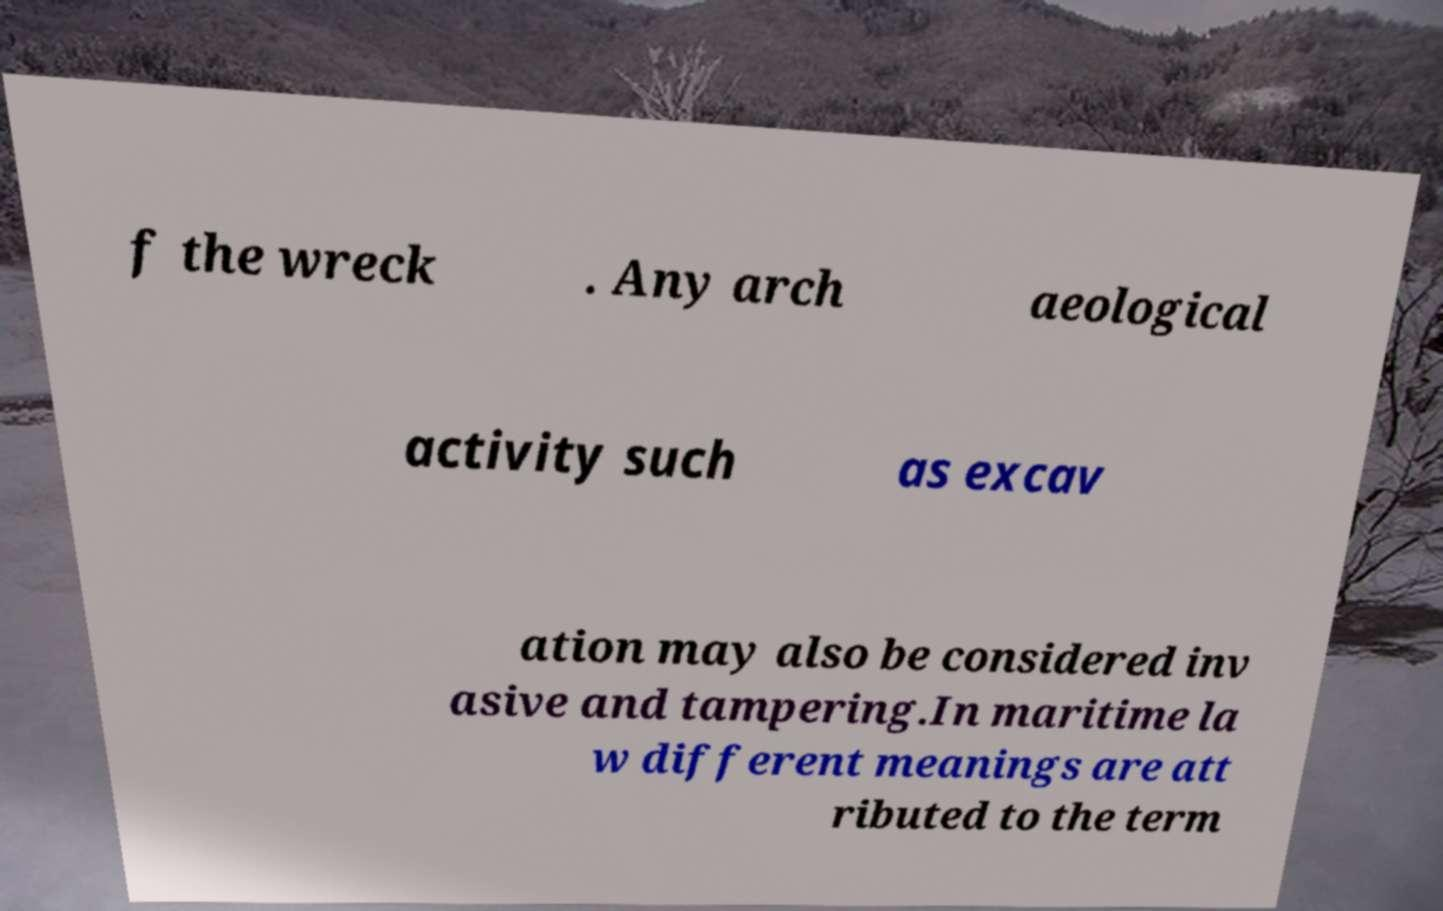I need the written content from this picture converted into text. Can you do that? f the wreck . Any arch aeological activity such as excav ation may also be considered inv asive and tampering.In maritime la w different meanings are att ributed to the term 